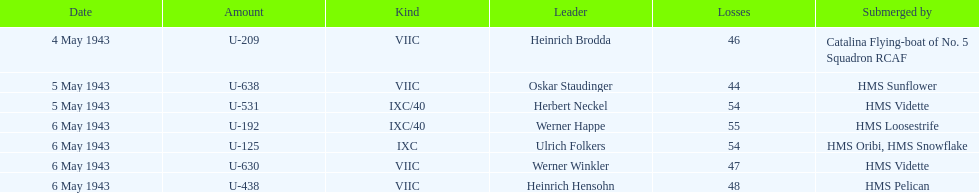Which date had at least 55 casualties? 6 May 1943. Can you parse all the data within this table? {'header': ['Date', 'Amount', 'Kind', 'Leader', 'Losses', 'Submerged by'], 'rows': [['4 May 1943', 'U-209', 'VIIC', 'Heinrich Brodda', '46', 'Catalina Flying-boat of No. 5 Squadron RCAF'], ['5 May 1943', 'U-638', 'VIIC', 'Oskar Staudinger', '44', 'HMS Sunflower'], ['5 May 1943', 'U-531', 'IXC/40', 'Herbert Neckel', '54', 'HMS Vidette'], ['6 May 1943', 'U-192', 'IXC/40', 'Werner Happe', '55', 'HMS Loosestrife'], ['6 May 1943', 'U-125', 'IXC', 'Ulrich Folkers', '54', 'HMS Oribi, HMS Snowflake'], ['6 May 1943', 'U-630', 'VIIC', 'Werner Winkler', '47', 'HMS Vidette'], ['6 May 1943', 'U-438', 'VIIC', 'Heinrich Hensohn', '48', 'HMS Pelican']]} 